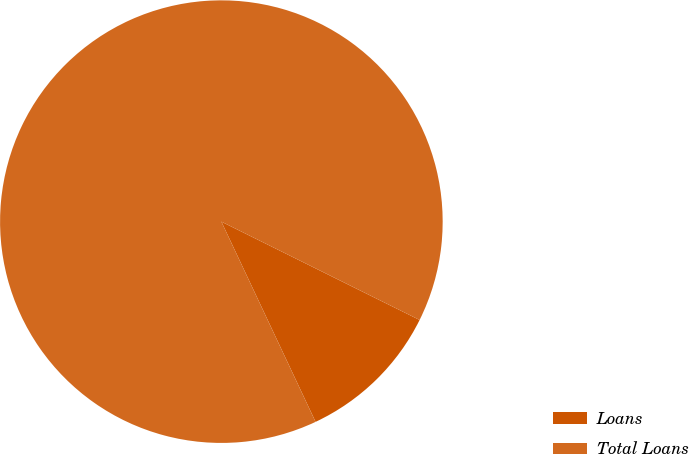Convert chart to OTSL. <chart><loc_0><loc_0><loc_500><loc_500><pie_chart><fcel>Loans<fcel>Total Loans<nl><fcel>10.67%<fcel>89.33%<nl></chart> 